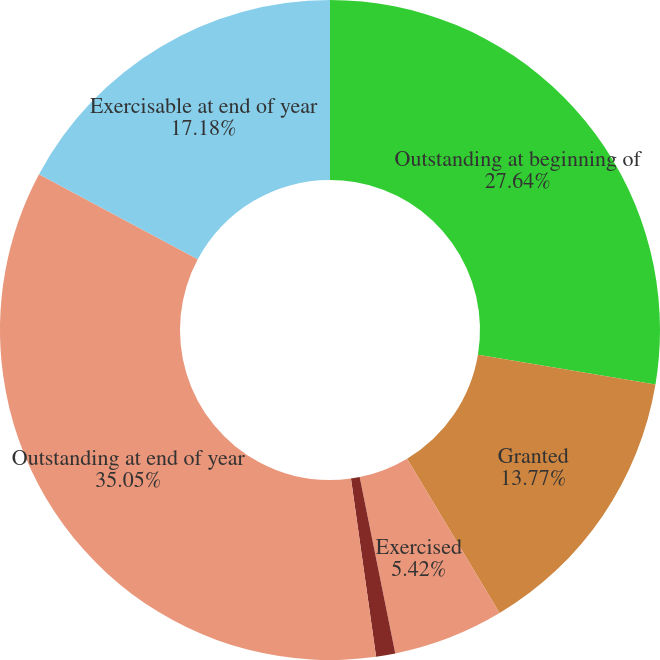Convert chart to OTSL. <chart><loc_0><loc_0><loc_500><loc_500><pie_chart><fcel>Outstanding at beginning of<fcel>Granted<fcel>Exercised<fcel>Forfeited<fcel>Outstanding at end of year<fcel>Exercisable at end of year<nl><fcel>27.64%<fcel>13.77%<fcel>5.42%<fcel>0.94%<fcel>35.05%<fcel>17.18%<nl></chart> 